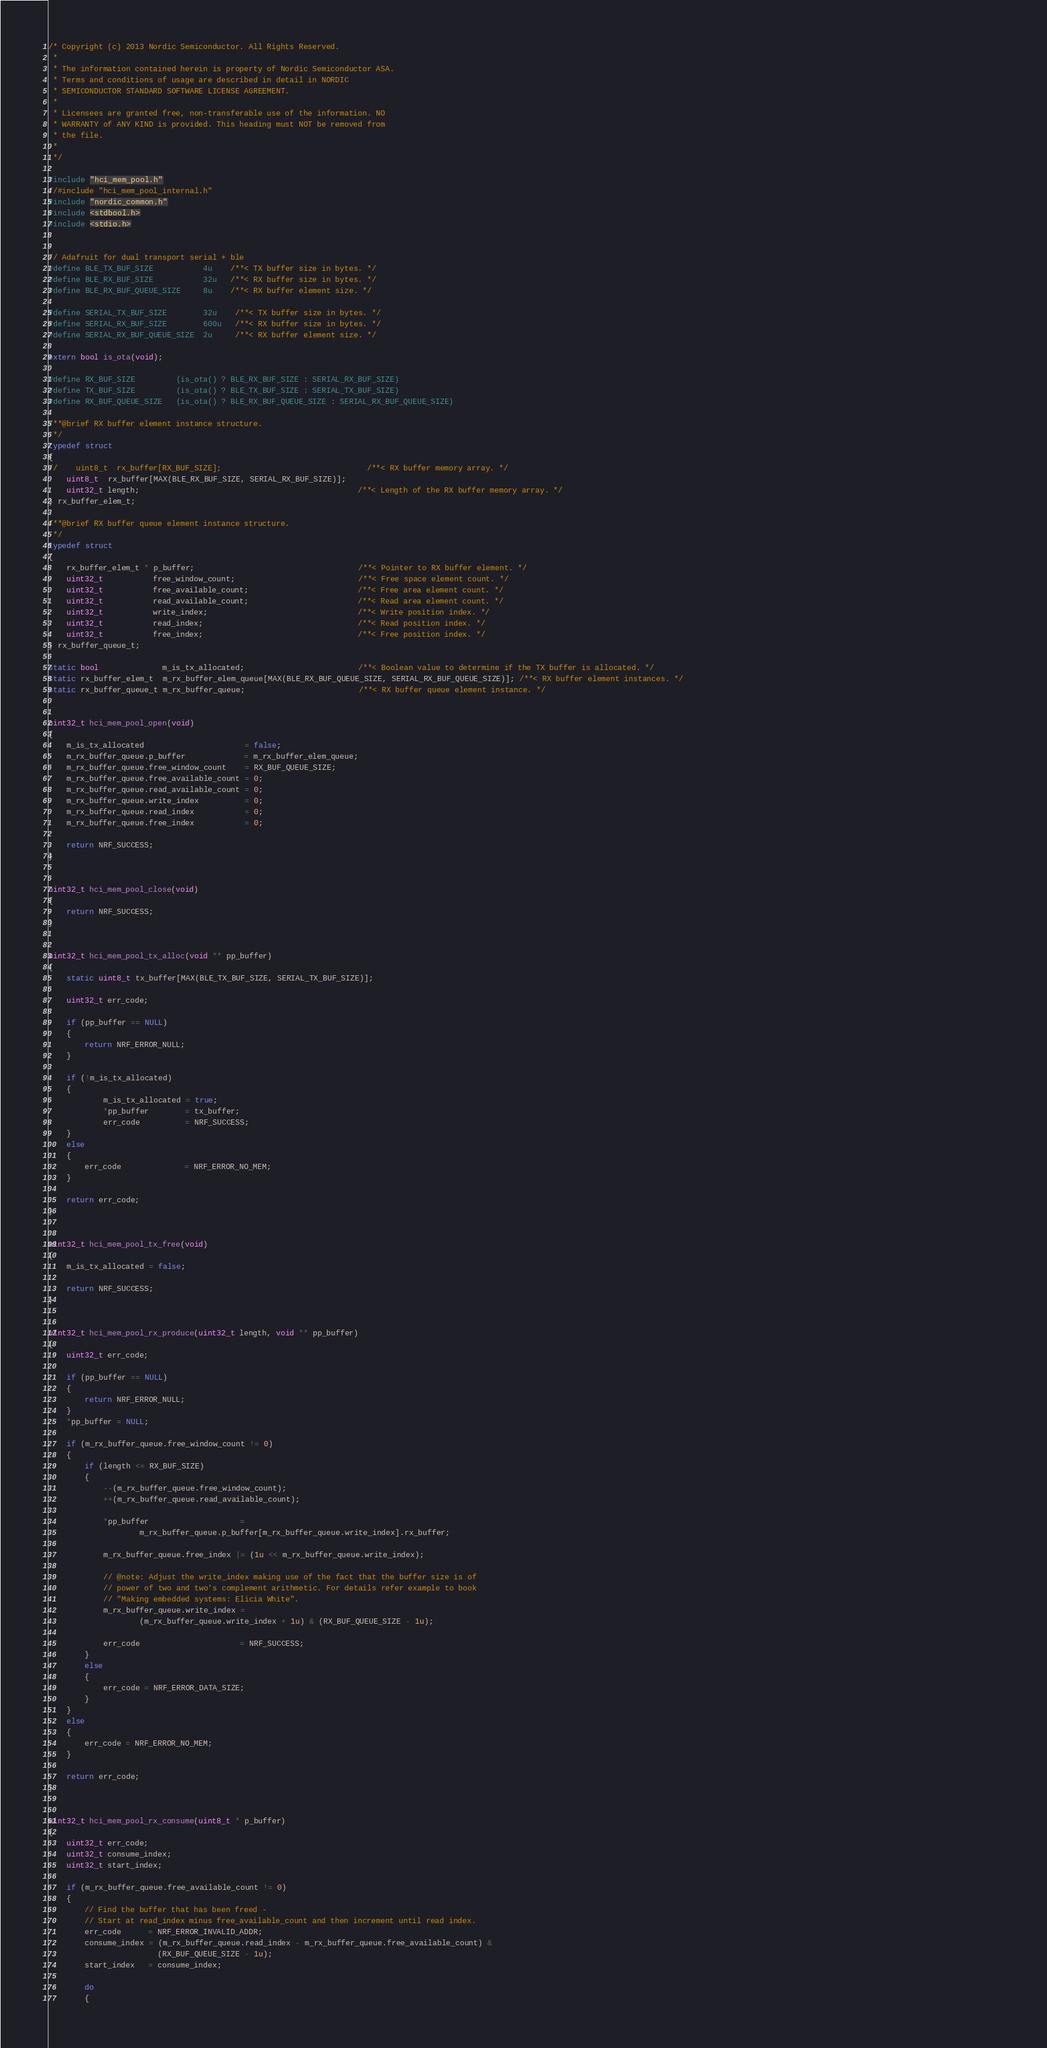Convert code to text. <code><loc_0><loc_0><loc_500><loc_500><_C_>/* Copyright (c) 2013 Nordic Semiconductor. All Rights Reserved.
 *
 * The information contained herein is property of Nordic Semiconductor ASA.
 * Terms and conditions of usage are described in detail in NORDIC
 * SEMICONDUCTOR STANDARD SOFTWARE LICENSE AGREEMENT.
 *
 * Licensees are granted free, non-transferable use of the information. NO
 * WARRANTY of ANY KIND is provided. This heading must NOT be removed from
 * the file.
 *
 */
 
#include "hci_mem_pool.h"
//#include "hci_mem_pool_internal.h"
#include "nordic_common.h"
#include <stdbool.h>
#include <stdio.h>


// Adafruit for dual transport serial + ble
#define BLE_TX_BUF_SIZE           4u    /**< TX buffer size in bytes. */
#define BLE_RX_BUF_SIZE           32u   /**< RX buffer size in bytes. */
#define BLE_RX_BUF_QUEUE_SIZE     8u    /**< RX buffer element size. */

#define SERIAL_TX_BUF_SIZE        32u    /**< TX buffer size in bytes. */
#define SERIAL_RX_BUF_SIZE        600u   /**< RX buffer size in bytes. */
#define SERIAL_RX_BUF_QUEUE_SIZE  2u     /**< RX buffer element size. */

extern bool is_ota(void);

#define RX_BUF_SIZE         (is_ota() ? BLE_RX_BUF_SIZE : SERIAL_RX_BUF_SIZE)
#define TX_BUF_SIZE         (is_ota() ? BLE_TX_BUF_SIZE : SERIAL_TX_BUF_SIZE)
#define RX_BUF_QUEUE_SIZE   (is_ota() ? BLE_RX_BUF_QUEUE_SIZE : SERIAL_RX_BUF_QUEUE_SIZE)

/**@brief RX buffer element instance structure. 
 */
typedef struct 
{
//    uint8_t  rx_buffer[RX_BUF_SIZE];                                /**< RX buffer memory array. */
    uint8_t  rx_buffer[MAX(BLE_RX_BUF_SIZE, SERIAL_RX_BUF_SIZE)];
    uint32_t length;                                                /**< Length of the RX buffer memory array. */
} rx_buffer_elem_t;

/**@brief RX buffer queue element instance structure. 
 */
typedef struct 
{
    rx_buffer_elem_t * p_buffer;                                    /**< Pointer to RX buffer element. */
    uint32_t           free_window_count;                           /**< Free space element count. */
    uint32_t           free_available_count;                        /**< Free area element count. */
    uint32_t           read_available_count;                        /**< Read area element count. */
    uint32_t           write_index;                                 /**< Write position index. */                                      
    uint32_t           read_index;                                  /**< Read position index. */                                                                            
    uint32_t           free_index;                                  /**< Free position index. */                                                                                                                  
} rx_buffer_queue_t;

static bool              m_is_tx_allocated;                         /**< Boolean value to determine if the TX buffer is allocated. */
static rx_buffer_elem_t  m_rx_buffer_elem_queue[MAX(BLE_RX_BUF_QUEUE_SIZE, SERIAL_RX_BUF_QUEUE_SIZE)]; /**< RX buffer element instances. */
static rx_buffer_queue_t m_rx_buffer_queue;                         /**< RX buffer queue element instance. */


uint32_t hci_mem_pool_open(void)
{
    m_is_tx_allocated                      = false;    
    m_rx_buffer_queue.p_buffer             = m_rx_buffer_elem_queue;
    m_rx_buffer_queue.free_window_count    = RX_BUF_QUEUE_SIZE;
    m_rx_buffer_queue.free_available_count = 0;
    m_rx_buffer_queue.read_available_count = 0;
    m_rx_buffer_queue.write_index          = 0;    
    m_rx_buffer_queue.read_index           = 0;        
    m_rx_buffer_queue.free_index           = 0;            
    
    return NRF_SUCCESS;
}


uint32_t hci_mem_pool_close(void)
{    
    return NRF_SUCCESS;
}


uint32_t hci_mem_pool_tx_alloc(void ** pp_buffer)
{
    static uint8_t tx_buffer[MAX(BLE_TX_BUF_SIZE, SERIAL_TX_BUF_SIZE)];

    uint32_t err_code;
    
    if (pp_buffer == NULL)
    {
        return NRF_ERROR_NULL;
    }
    
    if (!m_is_tx_allocated)
    {        
            m_is_tx_allocated = true;
            *pp_buffer        = tx_buffer;
            err_code          = NRF_SUCCESS;
    }
    else
    {
        err_code              = NRF_ERROR_NO_MEM;
    }
    
    return err_code;
}


uint32_t hci_mem_pool_tx_free(void)
{
    m_is_tx_allocated = false;
    
    return NRF_SUCCESS;
}


uint32_t hci_mem_pool_rx_produce(uint32_t length, void ** pp_buffer)
{
    uint32_t err_code; 

    if (pp_buffer == NULL)
    {
        return NRF_ERROR_NULL;
    }    
    *pp_buffer = NULL;
    
    if (m_rx_buffer_queue.free_window_count != 0)
    {    
        if (length <= RX_BUF_SIZE)
        {    
            --(m_rx_buffer_queue.free_window_count);            
            ++(m_rx_buffer_queue.read_available_count);            

            *pp_buffer                    = 
                    m_rx_buffer_queue.p_buffer[m_rx_buffer_queue.write_index].rx_buffer;

            m_rx_buffer_queue.free_index |= (1u << m_rx_buffer_queue.write_index);

            // @note: Adjust the write_index making use of the fact that the buffer size is of 
            // power of two and two's complement arithmetic. For details refer example to book 
            // "Making embedded systems: Elicia White".
            m_rx_buffer_queue.write_index = 
                    (m_rx_buffer_queue.write_index + 1u) & (RX_BUF_QUEUE_SIZE - 1u);
            
            err_code                      = NRF_SUCCESS;
        }
        else
        {
            err_code = NRF_ERROR_DATA_SIZE;    
        }        
    }
    else
    {
        err_code = NRF_ERROR_NO_MEM;    
    }
    
    return err_code;
}


uint32_t hci_mem_pool_rx_consume(uint8_t * p_buffer)
{
    uint32_t err_code;
    uint32_t consume_index;
    uint32_t start_index;
    
    if (m_rx_buffer_queue.free_available_count != 0)
    {
        // Find the buffer that has been freed -
        // Start at read_index minus free_available_count and then increment until read index.
        err_code      = NRF_ERROR_INVALID_ADDR;
        consume_index = (m_rx_buffer_queue.read_index - m_rx_buffer_queue.free_available_count) & 
                        (RX_BUF_QUEUE_SIZE - 1u);
        start_index   = consume_index;
        
        do
        {</code> 